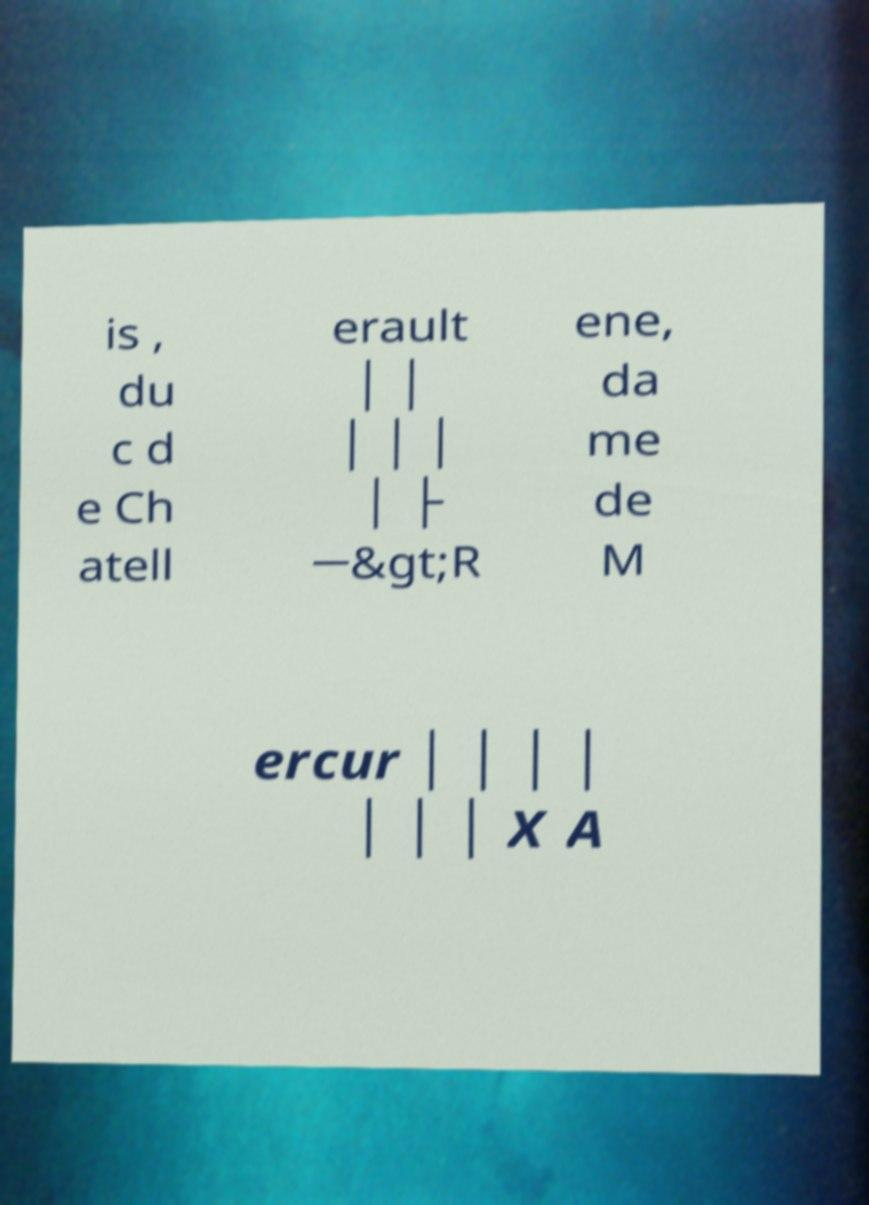Please identify and transcribe the text found in this image. is , du c d e Ch atell erault │ │ │ │ │ │ ├ ─&gt;R ene, da me de M ercur │ │ │ │ │ │ │ X A 